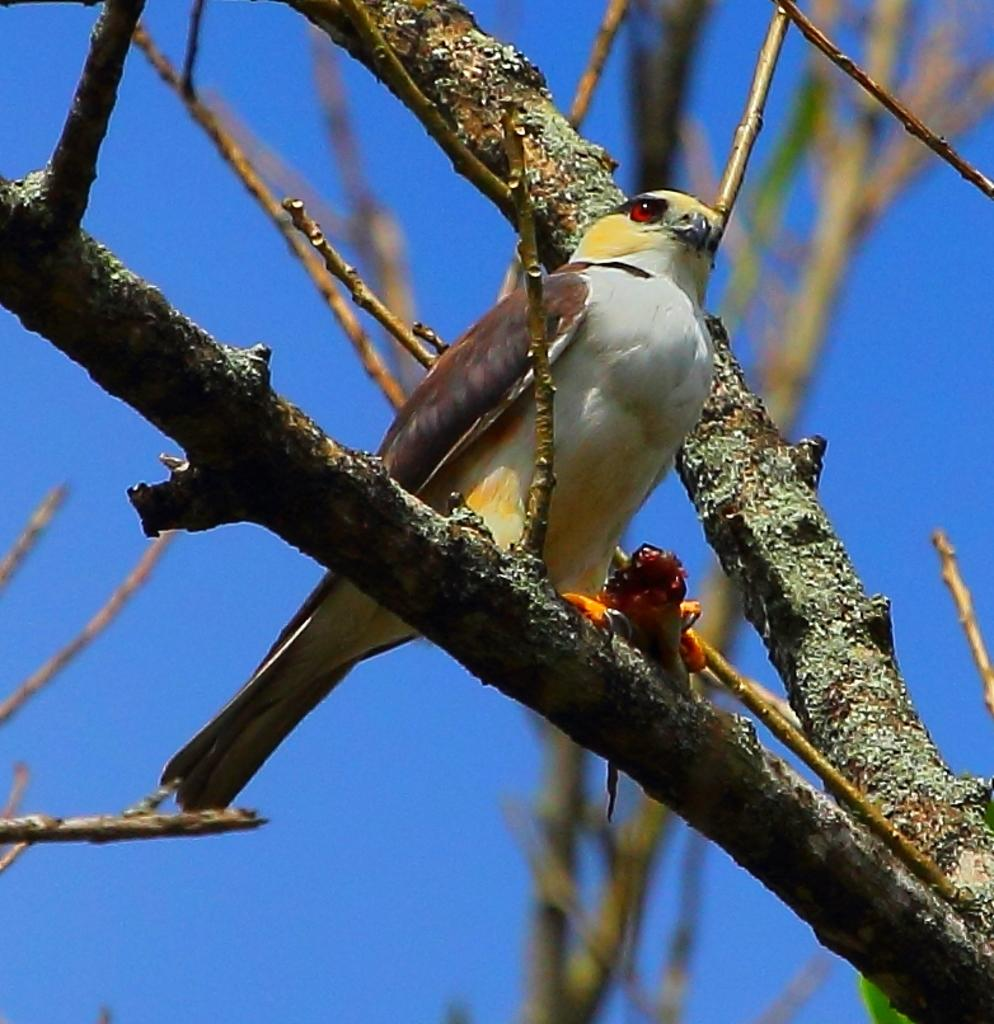What type of animal can be seen in the image? There is a bird in the image. Where is the bird located? The bird is on the branch of a tree. What colors can be observed on the bird? The bird has white, brown, and yellow colors. What can be seen in the background of the image? There is a sky visible in the background of the image. What type of string is the bird holding in its beak in the image? There is no string present in the image; the bird is simply perched on a tree branch. 